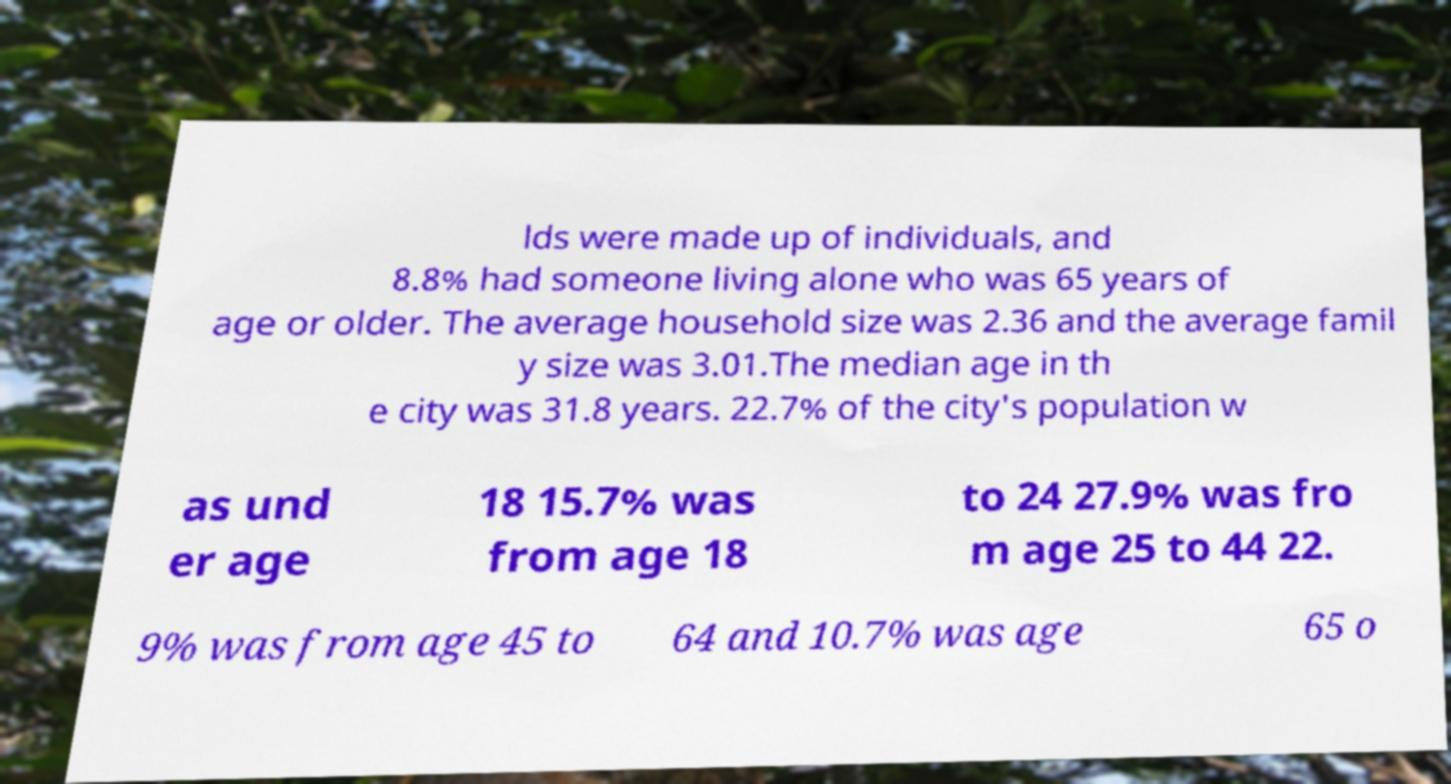Please read and relay the text visible in this image. What does it say? lds were made up of individuals, and 8.8% had someone living alone who was 65 years of age or older. The average household size was 2.36 and the average famil y size was 3.01.The median age in th e city was 31.8 years. 22.7% of the city's population w as und er age 18 15.7% was from age 18 to 24 27.9% was fro m age 25 to 44 22. 9% was from age 45 to 64 and 10.7% was age 65 o 